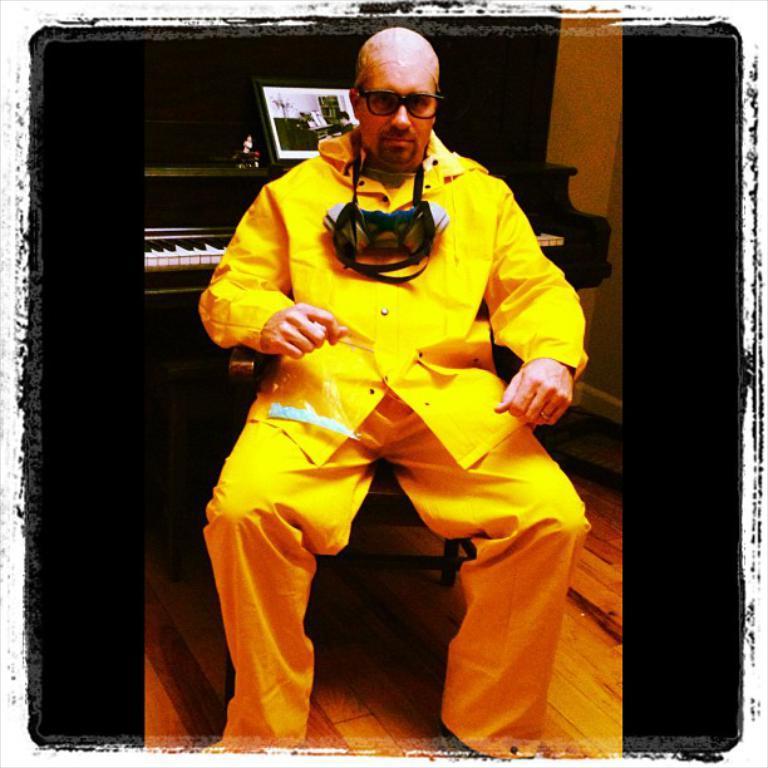Describe this image in one or two sentences. In this picture I can see there is a person sitting on the wooden chair, he is wearing a yellow shirt, pant and there is a piano behind him, with a book. 